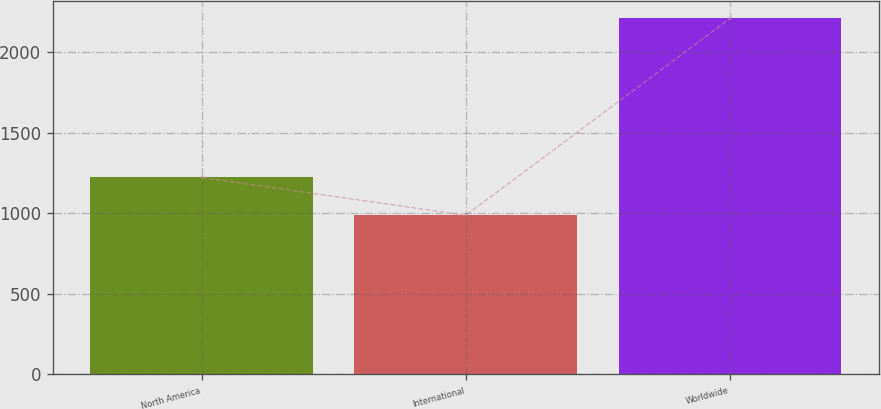<chart> <loc_0><loc_0><loc_500><loc_500><bar_chart><fcel>North America<fcel>International<fcel>Worldwide<nl><fcel>1223<fcel>988<fcel>2211<nl></chart> 